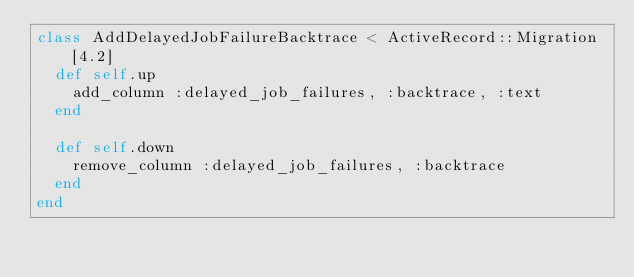<code> <loc_0><loc_0><loc_500><loc_500><_Ruby_>class AddDelayedJobFailureBacktrace < ActiveRecord::Migration[4.2]
  def self.up
    add_column :delayed_job_failures, :backtrace, :text
  end

  def self.down
    remove_column :delayed_job_failures, :backtrace
  end
end
</code> 